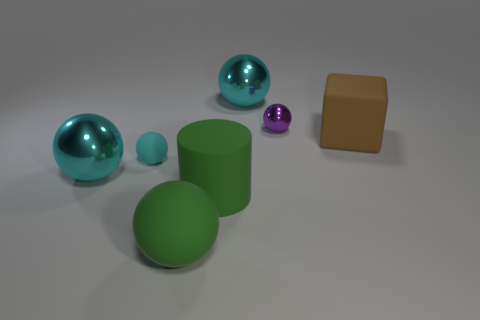The large object that is both behind the small cyan rubber object and in front of the purple thing has what shape?
Ensure brevity in your answer.  Cube. Does the big cyan thing behind the block have the same material as the green ball?
Offer a very short reply. No. What number of things are either large objects or large spheres that are behind the green cylinder?
Provide a succinct answer. 5. What color is the large cylinder that is the same material as the large brown object?
Give a very brief answer. Green. How many small cyan things have the same material as the large cylinder?
Offer a very short reply. 1. How many tiny metal things are there?
Give a very brief answer. 1. There is a large shiny ball that is right of the big rubber ball; does it have the same color as the large sphere to the left of the large green matte ball?
Offer a terse response. Yes. What number of large objects are in front of the purple object?
Provide a succinct answer. 4. There is a object that is the same color as the large cylinder; what is it made of?
Provide a short and direct response. Rubber. Are there any large metal objects that have the same shape as the brown matte object?
Offer a very short reply. No. 